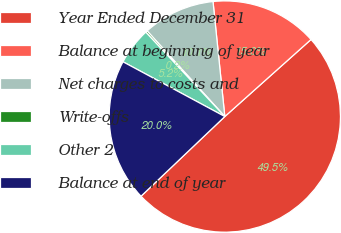<chart> <loc_0><loc_0><loc_500><loc_500><pie_chart><fcel>Year Ended December 31<fcel>Balance at beginning of year<fcel>Net charges to costs and<fcel>Write-offs<fcel>Other 2<fcel>Balance at end of year<nl><fcel>49.51%<fcel>15.02%<fcel>10.1%<fcel>0.25%<fcel>5.17%<fcel>19.95%<nl></chart> 